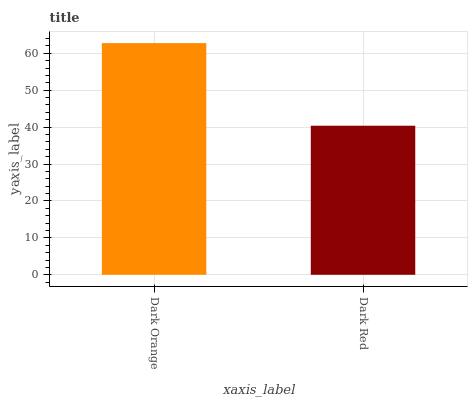Is Dark Red the minimum?
Answer yes or no. Yes. Is Dark Orange the maximum?
Answer yes or no. Yes. Is Dark Red the maximum?
Answer yes or no. No. Is Dark Orange greater than Dark Red?
Answer yes or no. Yes. Is Dark Red less than Dark Orange?
Answer yes or no. Yes. Is Dark Red greater than Dark Orange?
Answer yes or no. No. Is Dark Orange less than Dark Red?
Answer yes or no. No. Is Dark Orange the high median?
Answer yes or no. Yes. Is Dark Red the low median?
Answer yes or no. Yes. Is Dark Red the high median?
Answer yes or no. No. Is Dark Orange the low median?
Answer yes or no. No. 